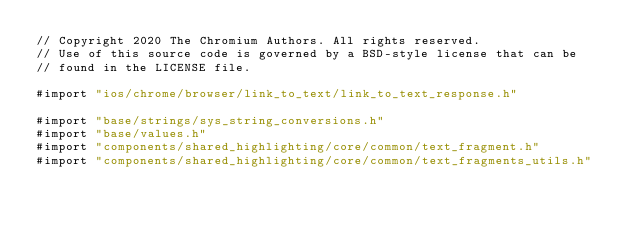Convert code to text. <code><loc_0><loc_0><loc_500><loc_500><_ObjectiveC_>// Copyright 2020 The Chromium Authors. All rights reserved.
// Use of this source code is governed by a BSD-style license that can be
// found in the LICENSE file.

#import "ios/chrome/browser/link_to_text/link_to_text_response.h"

#import "base/strings/sys_string_conversions.h"
#import "base/values.h"
#import "components/shared_highlighting/core/common/text_fragment.h"
#import "components/shared_highlighting/core/common/text_fragments_utils.h"</code> 